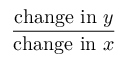<formula> <loc_0><loc_0><loc_500><loc_500>\frac { { c h a n g e i n } y } { { c h a n g e i n } x }</formula> 